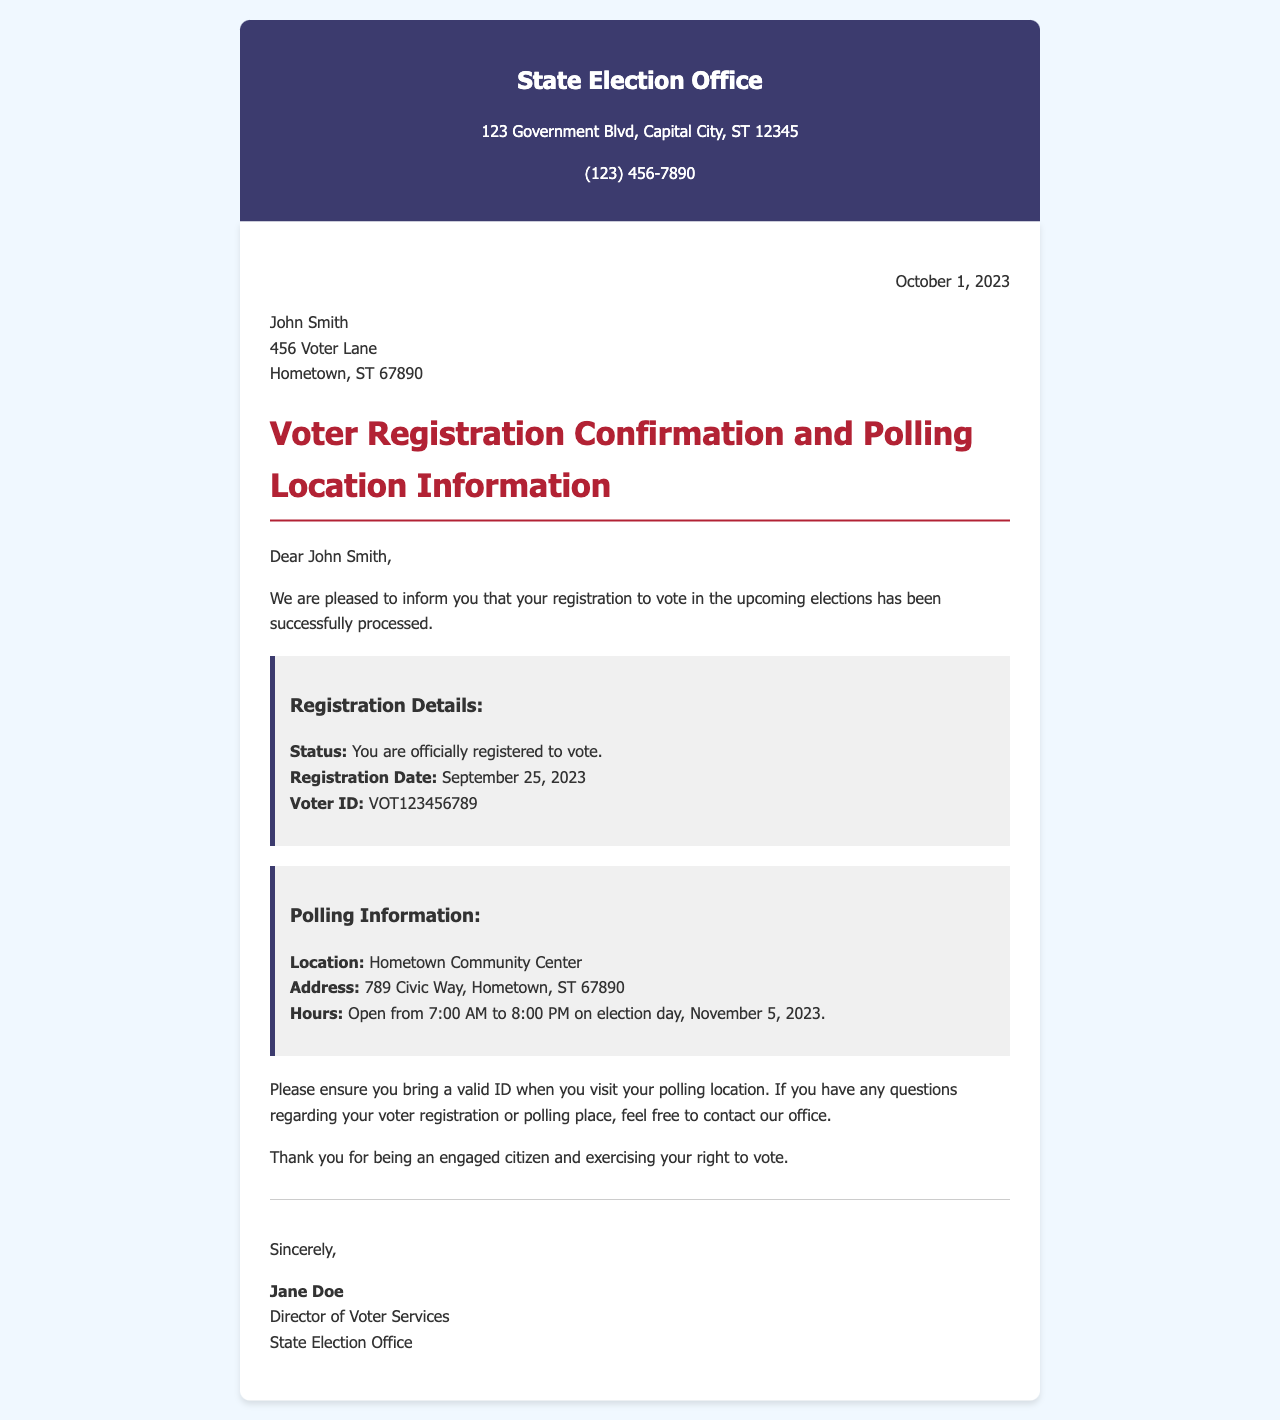What is the date of the letter? The letter is dated October 1, 2023, as stated at the top of the content.
Answer: October 1, 2023 What is the voter ID? The voter ID is mentioned in the registration details section of the letter.
Answer: VOT123456789 What is the polling location? The polling location is specified in the polling information section of the letter.
Answer: Hometown Community Center What are the polling hours? The polling hours are provided in the same section as the polling location.
Answer: Open from 7:00 AM to 8:00 PM Who sent the letter? The letter is signed by the Director of Voter Services, whose name is mentioned at the end.
Answer: Jane Doe What date was the voter registration processed? The registration date is indicated in the registration details section of the letter.
Answer: September 25, 2023 What is the address of the polling location? The address is included in the polling information section of the letter.
Answer: 789 Civic Way, Hometown, ST 67890 What is the suggested action when visiting the polling location? The letter advises bringing a valid ID when visiting the polling location.
Answer: Bring a valid ID 